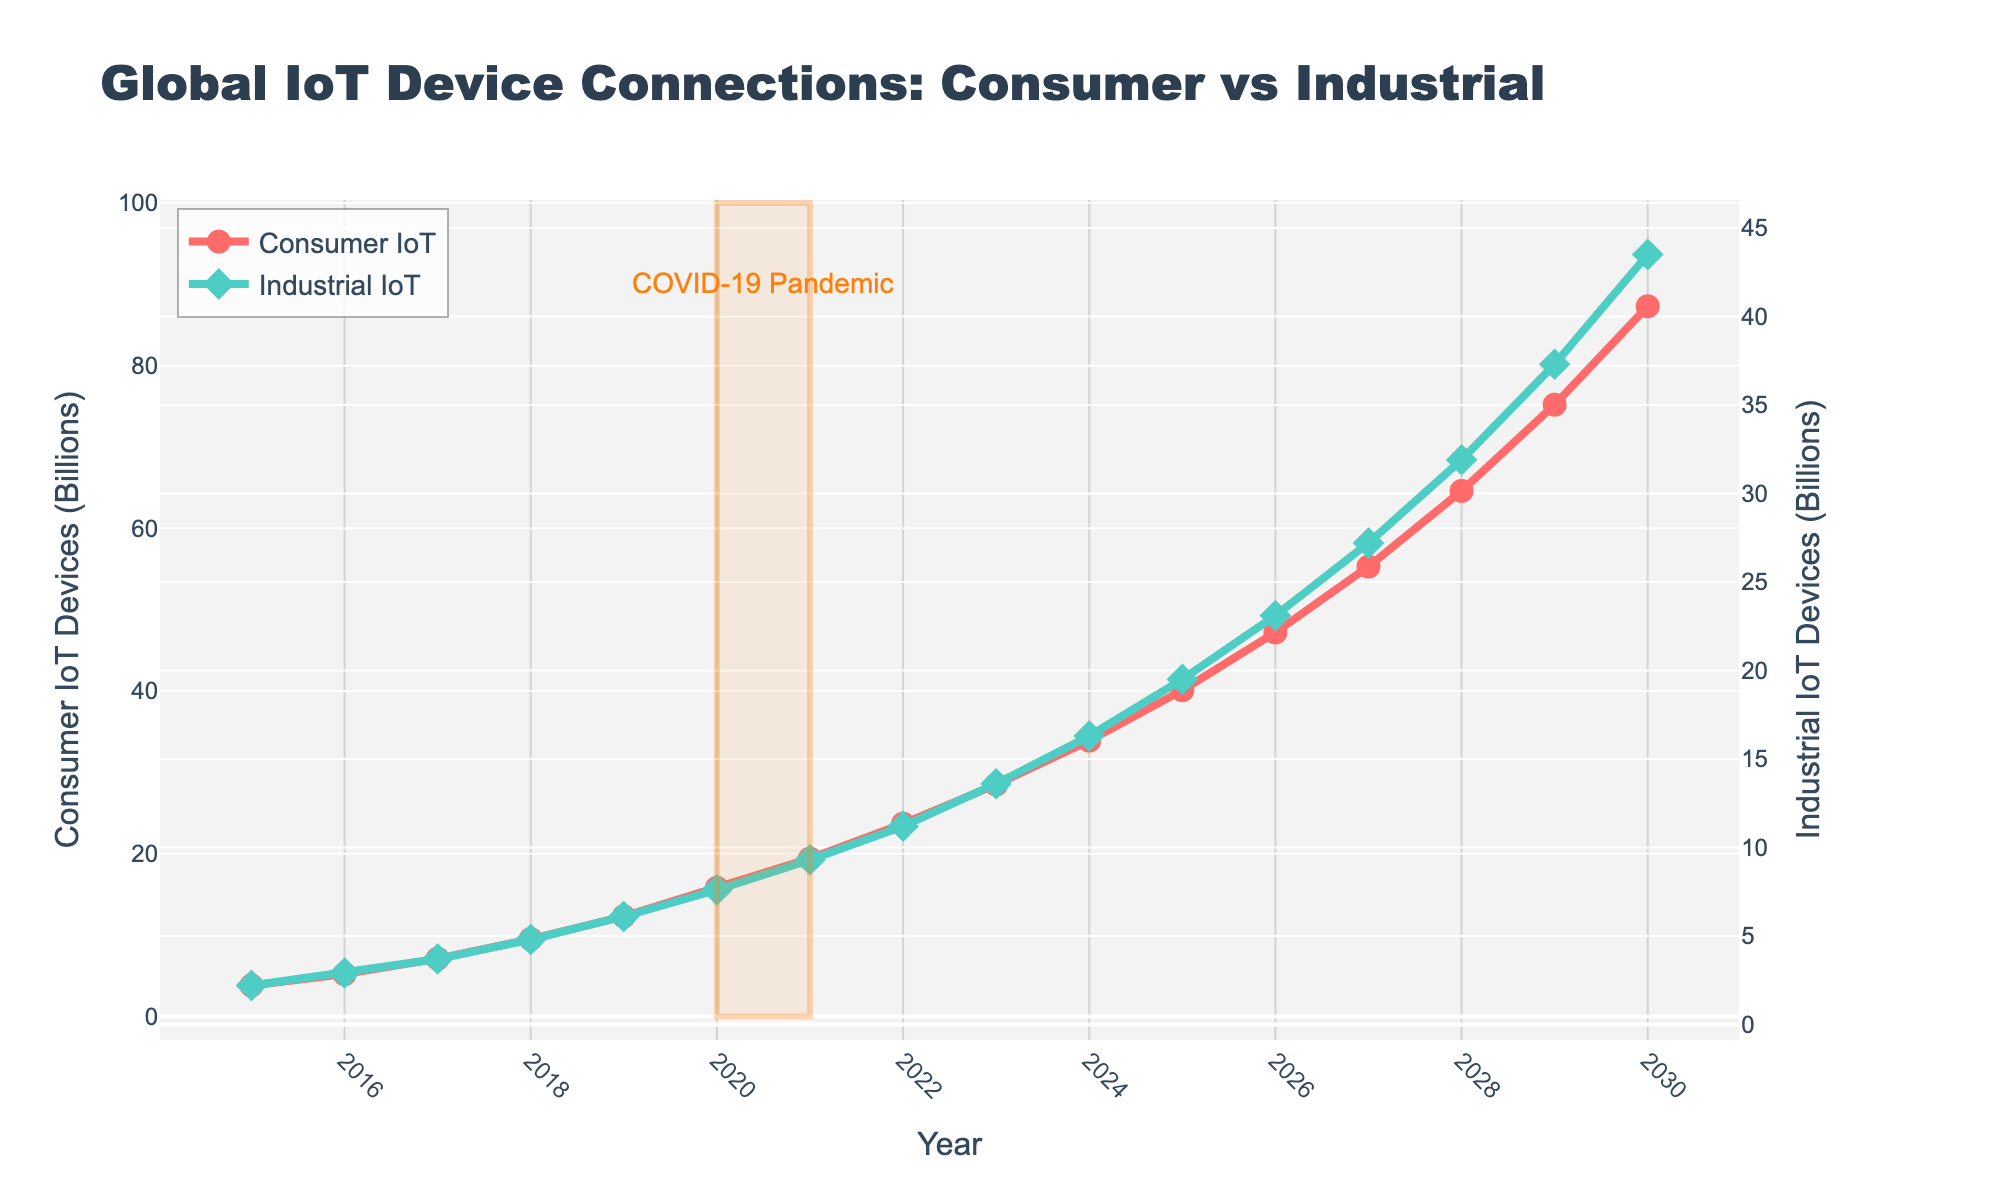What is the difference in the number of Consumer IoT devices between 2018 and 2020? In 2020, there are 15.8 billion Consumer IoT devices. In 2018, there are 9.5 billion. The difference is 15.8 - 9.5.
Answer: 6.3 billion Which type of IoT devices has a higher number in 2025 and by how much? In 2025, Consumer IoT devices are 40.1 billion and Industrial IoT devices are 19.5 billion. The Consumer IoT devices are higher by 40.1 - 19.5.
Answer: 20.6 billion How many total IoT devices are there globally in 2022? Add the Consumer IoT devices and Industrial IoT devices for 2022: 23.7 billion (Consumer) + 11.2 billion (Industrial).
Answer: 34.9 billion What can be observed about the trends of Consumer and Industrial IoT devices from 2015 to 2030? Both types of IoT devices show an increasing trend over the years. Consumer IoT devices grow from 3.8 billion in 2015 to 87.3 billion in 2030, while Industrial IoT devices grow from 2.2 billion in 2015 to 43.5 billion in 2030.
Answer: Both trend upwards During which year do Consumer IoT devices surpass 10 billion? The Consumer IoT devices surpass the 10 billion mark after 2018 (9.5 billion) but before 2019 (12.3 billion).
Answer: 2019 By how much did the number of Industrial IoT devices increase from 2023 to 2027? The number of Industrial IoT devices in 2027 is 27.2 billion, and in 2023 it is 13.6 billion. The increase is 27.2 - 13.6.
Answer: 13.6 billion What visual indication is used to highlight the COVID-19 Pandemic in the plot? The plot uses a rectangular shape highlighted in a light orange color around the years 2020 to 2021. There is also an annotation "COVID-19 Pandemic" around the highlighted area.
Answer: Rectangular highlight with annotation Which category of IoT devices has a steeper growth rate, Consumer or Industrial, between 2015 and 2030? From visual inspection, Consumer IoT devices increase from 3.8 billion to 87.3 billion, while Industrial IoT devices increase from 2.2 billion to 43.5 billion. The growth appears steeper for Consumer IoT devices due to a larger increase over the same period.
Answer: Consumer IoT What is the annual average increase in Consumer IoT devices from 2019 to 2023? Calculate the difference in Consumer IoT devices from 2019 (12.3 billion) to 2023 (28.5 billion), then divide by the number of years (4): (28.5 - 12.3) / 4.
Answer: 4.05 billion per year 